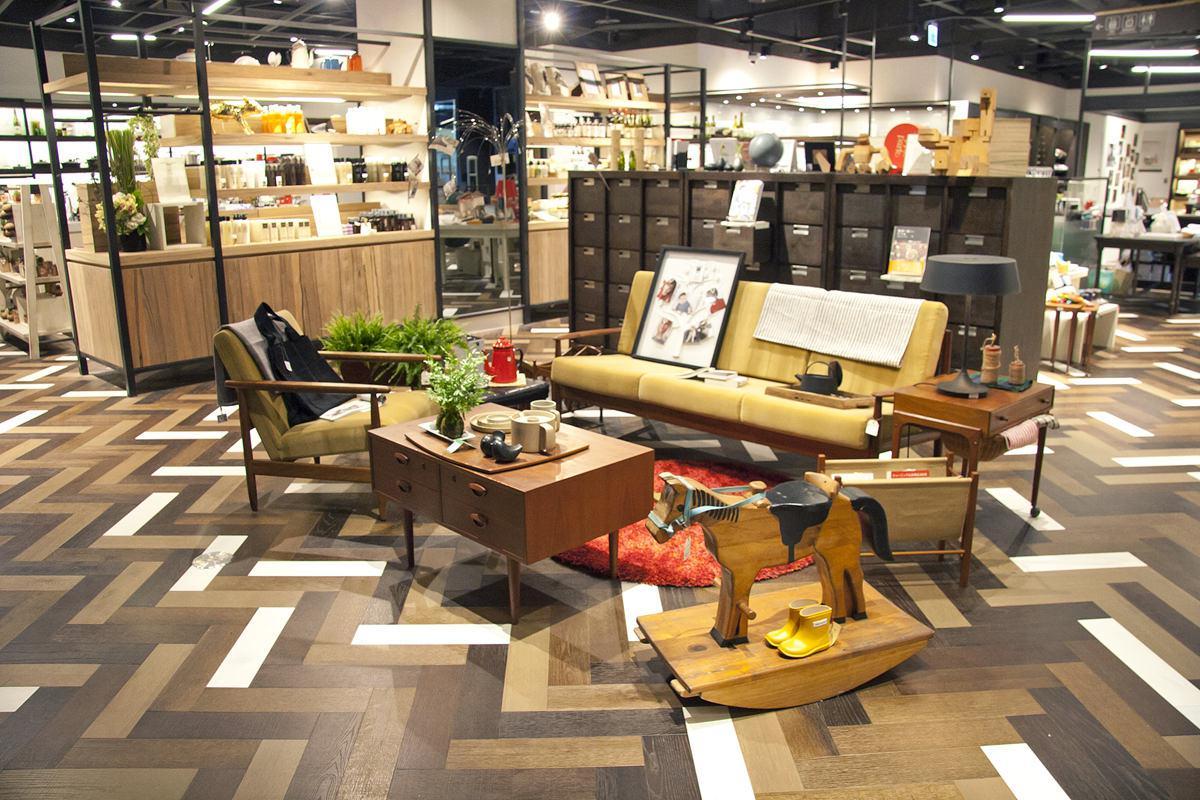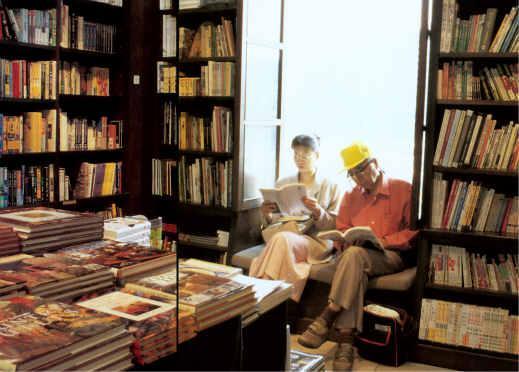The first image is the image on the left, the second image is the image on the right. Considering the images on both sides, is "Each image shows the outside window of the business." valid? Answer yes or no. No. The first image is the image on the left, the second image is the image on the right. Considering the images on both sides, is "There are people sitting." valid? Answer yes or no. Yes. 